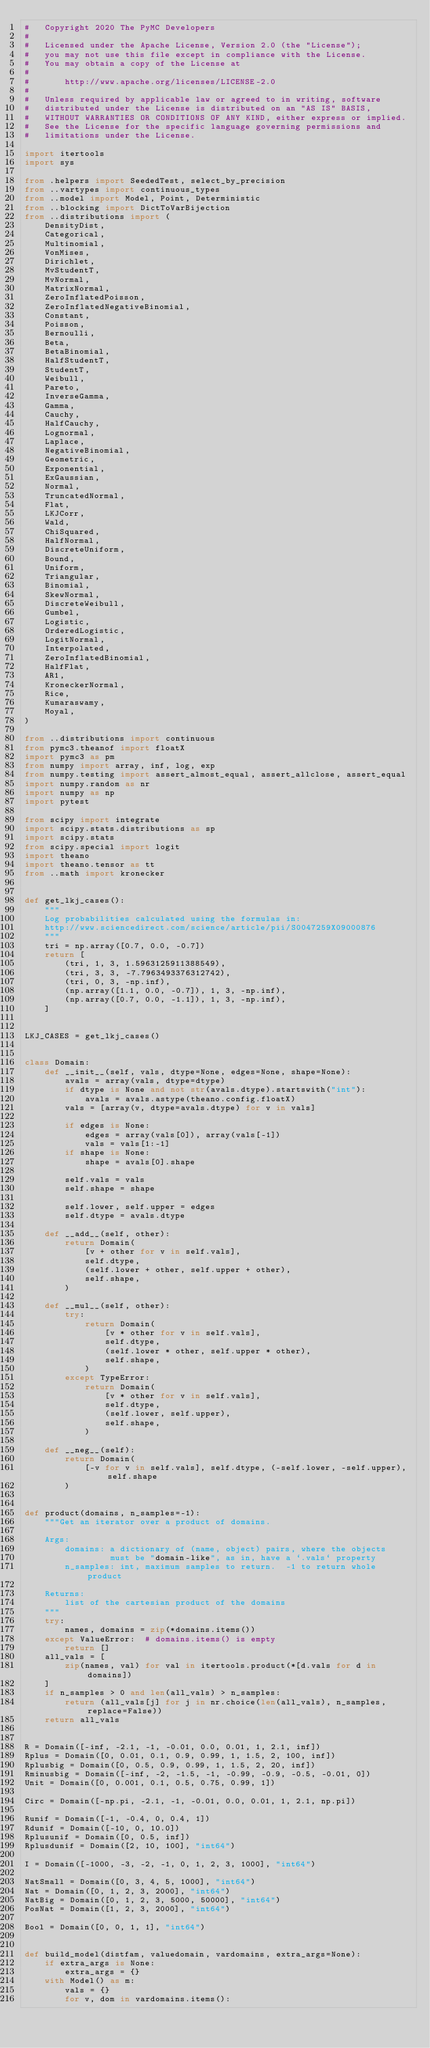Convert code to text. <code><loc_0><loc_0><loc_500><loc_500><_Python_>#   Copyright 2020 The PyMC Developers
#
#   Licensed under the Apache License, Version 2.0 (the "License");
#   you may not use this file except in compliance with the License.
#   You may obtain a copy of the License at
#
#       http://www.apache.org/licenses/LICENSE-2.0
#
#   Unless required by applicable law or agreed to in writing, software
#   distributed under the License is distributed on an "AS IS" BASIS,
#   WITHOUT WARRANTIES OR CONDITIONS OF ANY KIND, either express or implied.
#   See the License for the specific language governing permissions and
#   limitations under the License.

import itertools
import sys

from .helpers import SeededTest, select_by_precision
from ..vartypes import continuous_types
from ..model import Model, Point, Deterministic
from ..blocking import DictToVarBijection
from ..distributions import (
    DensityDist,
    Categorical,
    Multinomial,
    VonMises,
    Dirichlet,
    MvStudentT,
    MvNormal,
    MatrixNormal,
    ZeroInflatedPoisson,
    ZeroInflatedNegativeBinomial,
    Constant,
    Poisson,
    Bernoulli,
    Beta,
    BetaBinomial,
    HalfStudentT,
    StudentT,
    Weibull,
    Pareto,
    InverseGamma,
    Gamma,
    Cauchy,
    HalfCauchy,
    Lognormal,
    Laplace,
    NegativeBinomial,
    Geometric,
    Exponential,
    ExGaussian,
    Normal,
    TruncatedNormal,
    Flat,
    LKJCorr,
    Wald,
    ChiSquared,
    HalfNormal,
    DiscreteUniform,
    Bound,
    Uniform,
    Triangular,
    Binomial,
    SkewNormal,
    DiscreteWeibull,
    Gumbel,
    Logistic,
    OrderedLogistic,
    LogitNormal,
    Interpolated,
    ZeroInflatedBinomial,
    HalfFlat,
    AR1,
    KroneckerNormal,
    Rice,
    Kumaraswamy,
    Moyal,
)

from ..distributions import continuous
from pymc3.theanof import floatX
import pymc3 as pm
from numpy import array, inf, log, exp
from numpy.testing import assert_almost_equal, assert_allclose, assert_equal
import numpy.random as nr
import numpy as np
import pytest

from scipy import integrate
import scipy.stats.distributions as sp
import scipy.stats
from scipy.special import logit
import theano
import theano.tensor as tt
from ..math import kronecker


def get_lkj_cases():
    """
    Log probabilities calculated using the formulas in:
    http://www.sciencedirect.com/science/article/pii/S0047259X09000876
    """
    tri = np.array([0.7, 0.0, -0.7])
    return [
        (tri, 1, 3, 1.5963125911388549),
        (tri, 3, 3, -7.7963493376312742),
        (tri, 0, 3, -np.inf),
        (np.array([1.1, 0.0, -0.7]), 1, 3, -np.inf),
        (np.array([0.7, 0.0, -1.1]), 1, 3, -np.inf),
    ]


LKJ_CASES = get_lkj_cases()


class Domain:
    def __init__(self, vals, dtype=None, edges=None, shape=None):
        avals = array(vals, dtype=dtype)
        if dtype is None and not str(avals.dtype).startswith("int"):
            avals = avals.astype(theano.config.floatX)
        vals = [array(v, dtype=avals.dtype) for v in vals]

        if edges is None:
            edges = array(vals[0]), array(vals[-1])
            vals = vals[1:-1]
        if shape is None:
            shape = avals[0].shape

        self.vals = vals
        self.shape = shape

        self.lower, self.upper = edges
        self.dtype = avals.dtype

    def __add__(self, other):
        return Domain(
            [v + other for v in self.vals],
            self.dtype,
            (self.lower + other, self.upper + other),
            self.shape,
        )

    def __mul__(self, other):
        try:
            return Domain(
                [v * other for v in self.vals],
                self.dtype,
                (self.lower * other, self.upper * other),
                self.shape,
            )
        except TypeError:
            return Domain(
                [v * other for v in self.vals],
                self.dtype,
                (self.lower, self.upper),
                self.shape,
            )

    def __neg__(self):
        return Domain(
            [-v for v in self.vals], self.dtype, (-self.lower, -self.upper), self.shape
        )


def product(domains, n_samples=-1):
    """Get an iterator over a product of domains.

    Args:
        domains: a dictionary of (name, object) pairs, where the objects
                 must be "domain-like", as in, have a `.vals` property
        n_samples: int, maximum samples to return.  -1 to return whole product

    Returns:
        list of the cartesian product of the domains
    """
    try:
        names, domains = zip(*domains.items())
    except ValueError:  # domains.items() is empty
        return []
    all_vals = [
        zip(names, val) for val in itertools.product(*[d.vals for d in domains])
    ]
    if n_samples > 0 and len(all_vals) > n_samples:
        return (all_vals[j] for j in nr.choice(len(all_vals), n_samples, replace=False))
    return all_vals


R = Domain([-inf, -2.1, -1, -0.01, 0.0, 0.01, 1, 2.1, inf])
Rplus = Domain([0, 0.01, 0.1, 0.9, 0.99, 1, 1.5, 2, 100, inf])
Rplusbig = Domain([0, 0.5, 0.9, 0.99, 1, 1.5, 2, 20, inf])
Rminusbig = Domain([-inf, -2, -1.5, -1, -0.99, -0.9, -0.5, -0.01, 0])
Unit = Domain([0, 0.001, 0.1, 0.5, 0.75, 0.99, 1])

Circ = Domain([-np.pi, -2.1, -1, -0.01, 0.0, 0.01, 1, 2.1, np.pi])

Runif = Domain([-1, -0.4, 0, 0.4, 1])
Rdunif = Domain([-10, 0, 10.0])
Rplusunif = Domain([0, 0.5, inf])
Rplusdunif = Domain([2, 10, 100], "int64")

I = Domain([-1000, -3, -2, -1, 0, 1, 2, 3, 1000], "int64")

NatSmall = Domain([0, 3, 4, 5, 1000], "int64")
Nat = Domain([0, 1, 2, 3, 2000], "int64")
NatBig = Domain([0, 1, 2, 3, 5000, 50000], "int64")
PosNat = Domain([1, 2, 3, 2000], "int64")

Bool = Domain([0, 0, 1, 1], "int64")


def build_model(distfam, valuedomain, vardomains, extra_args=None):
    if extra_args is None:
        extra_args = {}
    with Model() as m:
        vals = {}
        for v, dom in vardomains.items():</code> 